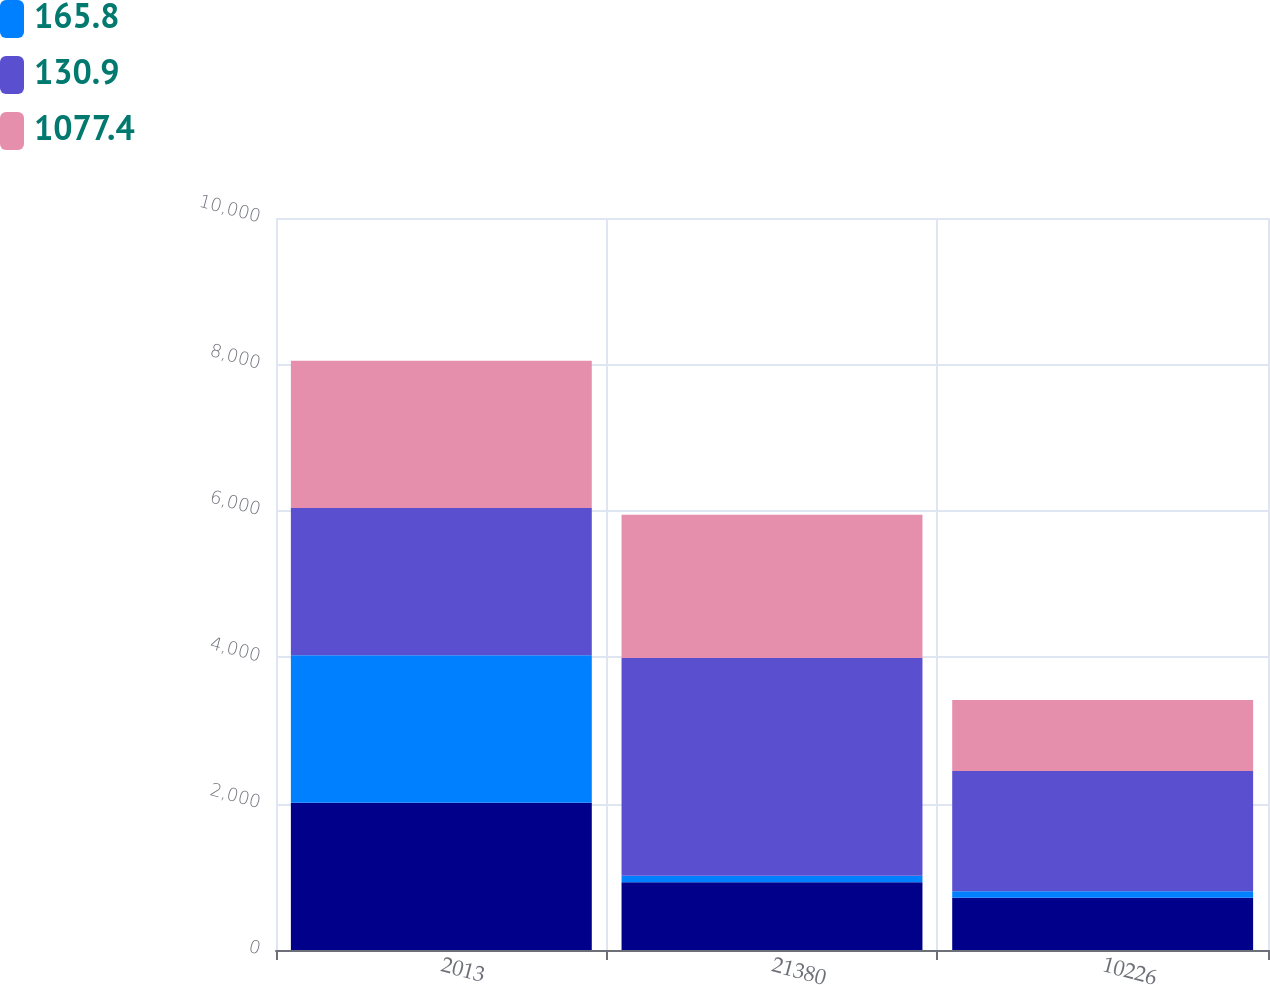Convert chart. <chart><loc_0><loc_0><loc_500><loc_500><stacked_bar_chart><ecel><fcel>2013<fcel>21380<fcel>10226<nl><fcel>nan<fcel>2013<fcel>924.7<fcel>712.1<nl><fcel>165.8<fcel>2013<fcel>90.2<fcel>90.2<nl><fcel>130.9<fcel>2013<fcel>2972.5<fcel>1644.5<nl><fcel>1077.4<fcel>2012<fcel>1958.3<fcel>967.6<nl></chart> 